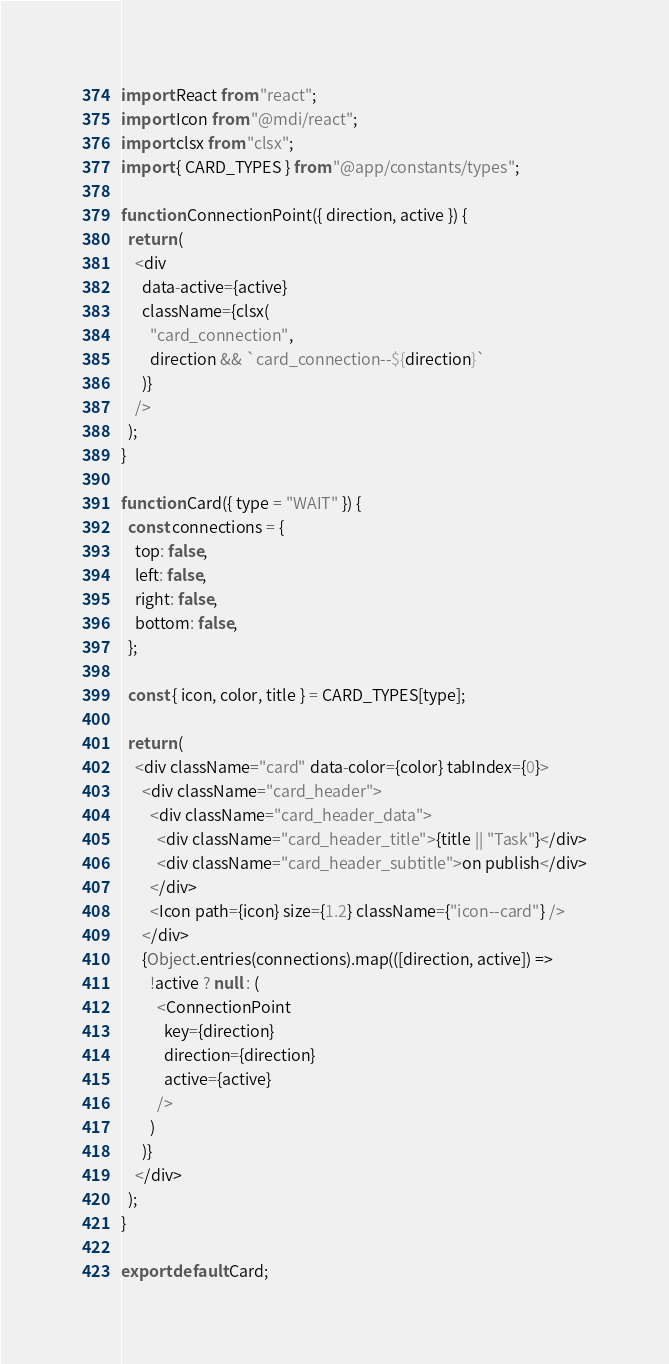<code> <loc_0><loc_0><loc_500><loc_500><_JavaScript_>import React from "react";
import Icon from "@mdi/react";
import clsx from "clsx";
import { CARD_TYPES } from "@app/constants/types";

function ConnectionPoint({ direction, active }) {
  return (
    <div
      data-active={active}
      className={clsx(
        "card_connection",
        direction && `card_connection--${direction}`
      )}
    />
  );
}

function Card({ type = "WAIT" }) {
  const connections = {
    top: false,
    left: false,
    right: false,
    bottom: false,
  };

  const { icon, color, title } = CARD_TYPES[type];

  return (
    <div className="card" data-color={color} tabIndex={0}>
      <div className="card_header">
        <div className="card_header_data">
          <div className="card_header_title">{title || "Task"}</div>
          <div className="card_header_subtitle">on publish</div>
        </div>
        <Icon path={icon} size={1.2} className={"icon--card"} />
      </div>
      {Object.entries(connections).map(([direction, active]) =>
        !active ? null : (
          <ConnectionPoint
            key={direction}
            direction={direction}
            active={active}
          />
        )
      )}
    </div>
  );
}

export default Card;
</code> 